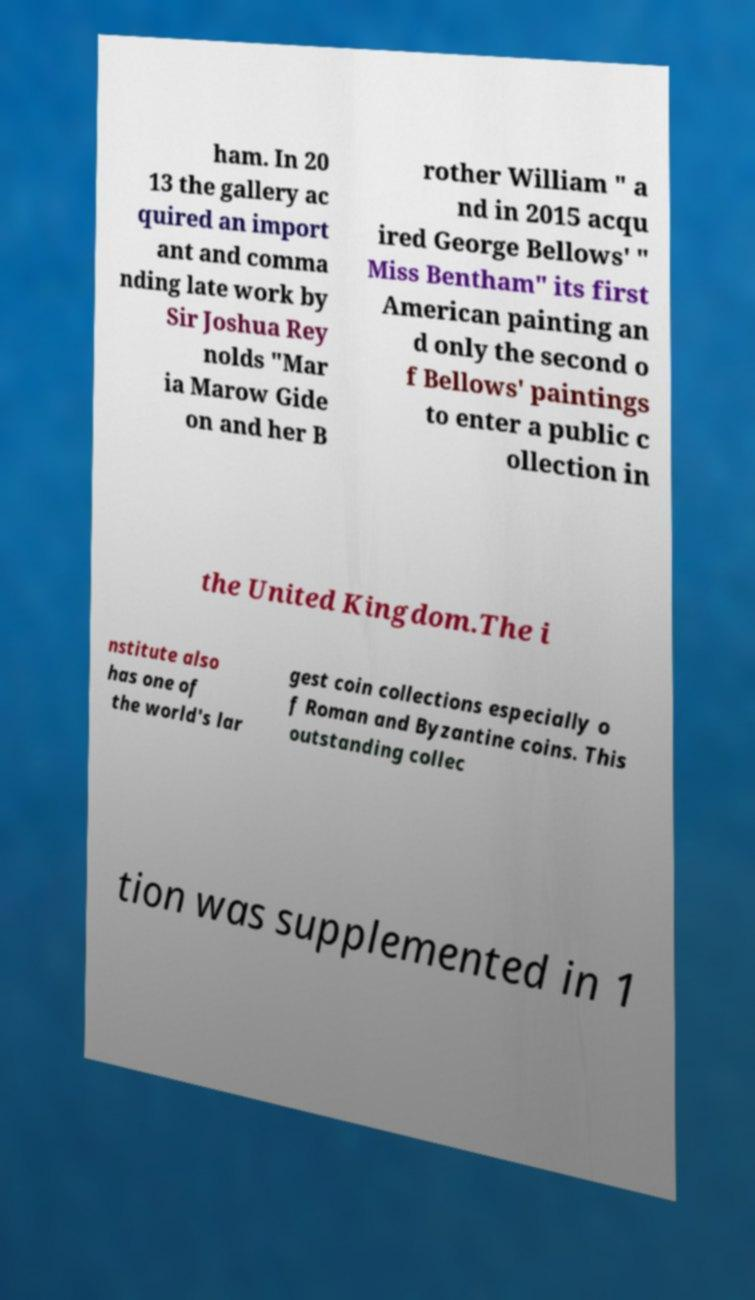What messages or text are displayed in this image? I need them in a readable, typed format. ham. In 20 13 the gallery ac quired an import ant and comma nding late work by Sir Joshua Rey nolds "Mar ia Marow Gide on and her B rother William " a nd in 2015 acqu ired George Bellows' " Miss Bentham" its first American painting an d only the second o f Bellows' paintings to enter a public c ollection in the United Kingdom.The i nstitute also has one of the world's lar gest coin collections especially o f Roman and Byzantine coins. This outstanding collec tion was supplemented in 1 